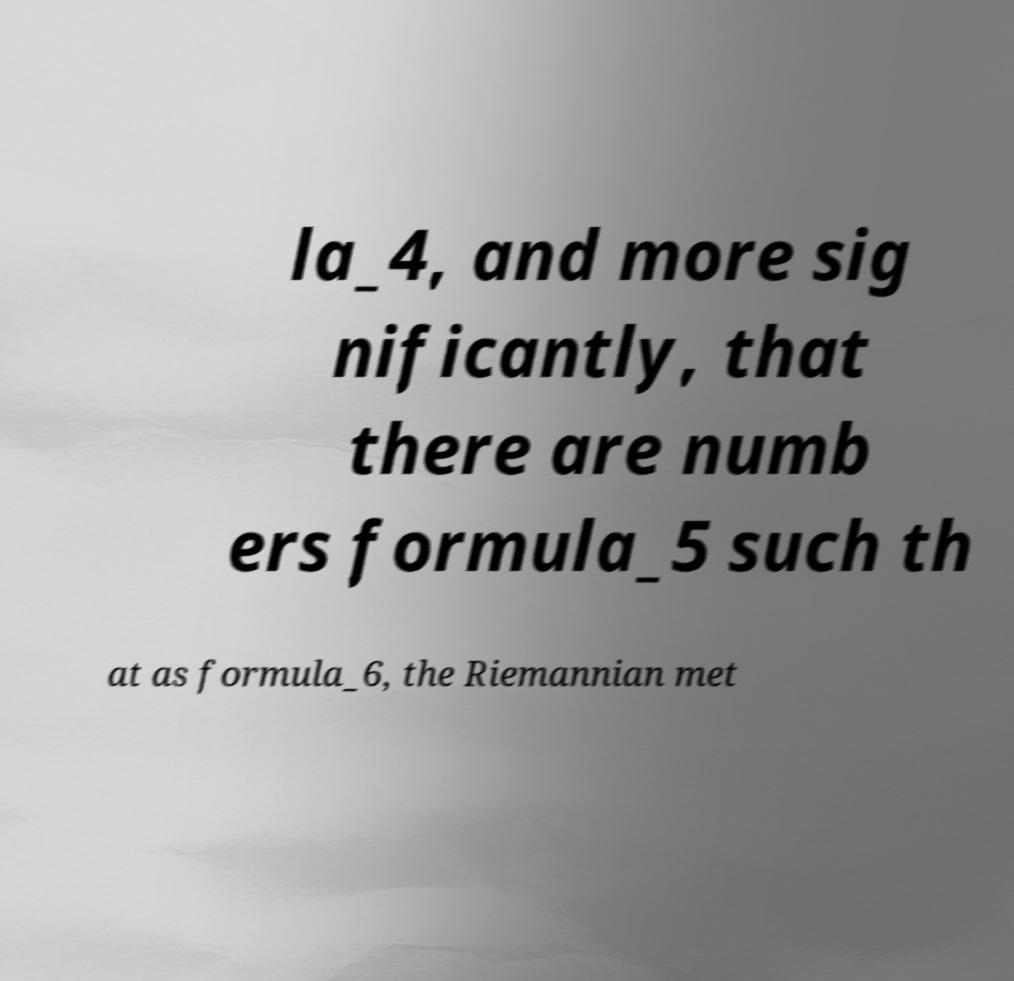Could you extract and type out the text from this image? la_4, and more sig nificantly, that there are numb ers formula_5 such th at as formula_6, the Riemannian met 